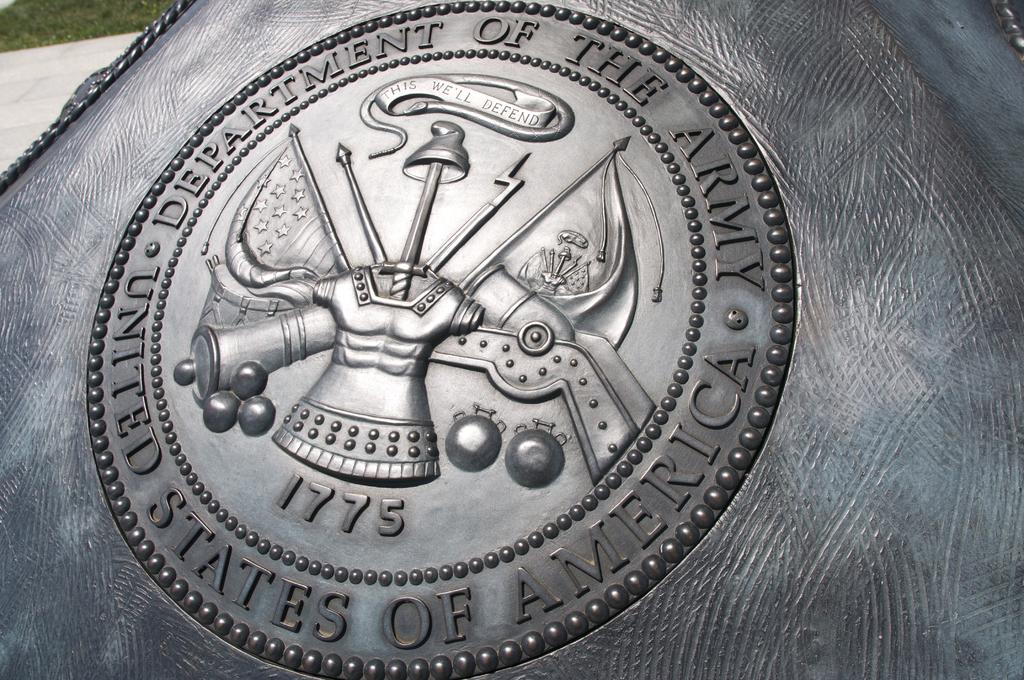What year is this plaque celebrating?
Your response must be concise. 1775. What country is on this plaque?
Make the answer very short. United states of america. 